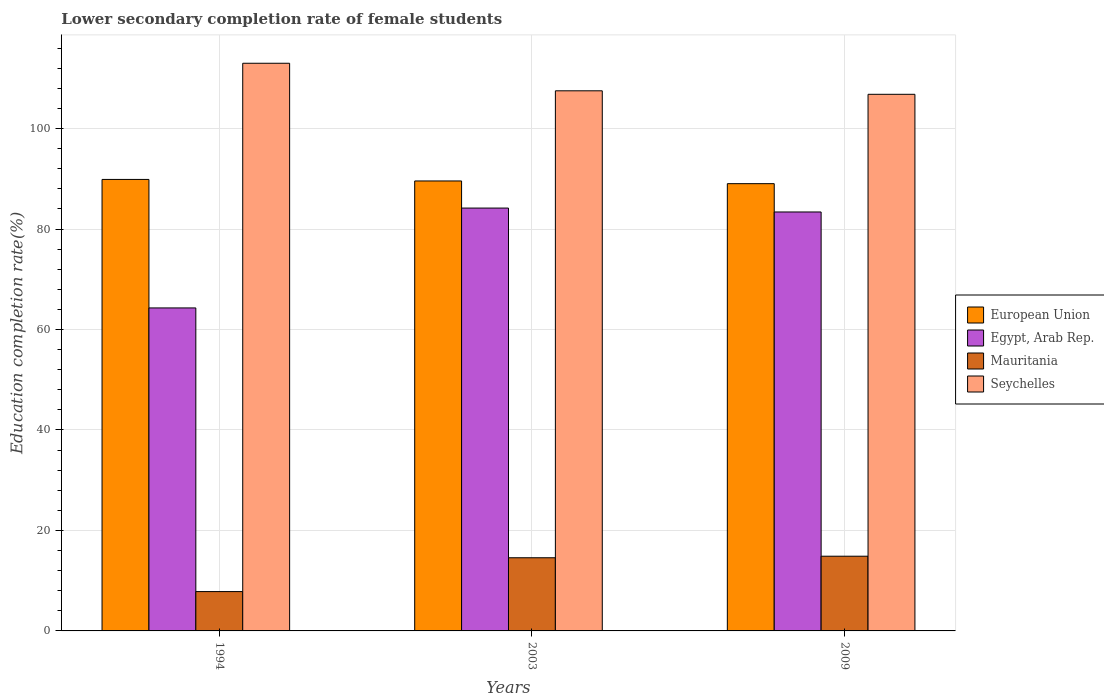How many groups of bars are there?
Your response must be concise. 3. How many bars are there on the 1st tick from the right?
Offer a terse response. 4. In how many cases, is the number of bars for a given year not equal to the number of legend labels?
Offer a very short reply. 0. What is the lower secondary completion rate of female students in European Union in 2003?
Ensure brevity in your answer.  89.57. Across all years, what is the maximum lower secondary completion rate of female students in Egypt, Arab Rep.?
Make the answer very short. 84.18. Across all years, what is the minimum lower secondary completion rate of female students in Egypt, Arab Rep.?
Make the answer very short. 64.3. In which year was the lower secondary completion rate of female students in Egypt, Arab Rep. maximum?
Keep it short and to the point. 2003. What is the total lower secondary completion rate of female students in Egypt, Arab Rep. in the graph?
Give a very brief answer. 231.87. What is the difference between the lower secondary completion rate of female students in Egypt, Arab Rep. in 2003 and that in 2009?
Make the answer very short. 0.78. What is the difference between the lower secondary completion rate of female students in Egypt, Arab Rep. in 2003 and the lower secondary completion rate of female students in European Union in 2009?
Keep it short and to the point. -4.86. What is the average lower secondary completion rate of female students in Seychelles per year?
Provide a succinct answer. 109.11. In the year 1994, what is the difference between the lower secondary completion rate of female students in European Union and lower secondary completion rate of female students in Mauritania?
Ensure brevity in your answer.  82.05. What is the ratio of the lower secondary completion rate of female students in European Union in 1994 to that in 2009?
Give a very brief answer. 1.01. What is the difference between the highest and the second highest lower secondary completion rate of female students in Mauritania?
Keep it short and to the point. 0.31. What is the difference between the highest and the lowest lower secondary completion rate of female students in Mauritania?
Give a very brief answer. 7.04. In how many years, is the lower secondary completion rate of female students in European Union greater than the average lower secondary completion rate of female students in European Union taken over all years?
Provide a succinct answer. 2. Is the sum of the lower secondary completion rate of female students in Mauritania in 1994 and 2009 greater than the maximum lower secondary completion rate of female students in European Union across all years?
Offer a very short reply. No. Is it the case that in every year, the sum of the lower secondary completion rate of female students in Seychelles and lower secondary completion rate of female students in European Union is greater than the sum of lower secondary completion rate of female students in Egypt, Arab Rep. and lower secondary completion rate of female students in Mauritania?
Give a very brief answer. Yes. What does the 1st bar from the left in 2003 represents?
Offer a terse response. European Union. Is it the case that in every year, the sum of the lower secondary completion rate of female students in Seychelles and lower secondary completion rate of female students in Egypt, Arab Rep. is greater than the lower secondary completion rate of female students in Mauritania?
Your response must be concise. Yes. Are all the bars in the graph horizontal?
Keep it short and to the point. No. What is the difference between two consecutive major ticks on the Y-axis?
Your response must be concise. 20. Are the values on the major ticks of Y-axis written in scientific E-notation?
Offer a very short reply. No. Does the graph contain grids?
Ensure brevity in your answer.  Yes. How are the legend labels stacked?
Provide a succinct answer. Vertical. What is the title of the graph?
Your answer should be very brief. Lower secondary completion rate of female students. Does "Syrian Arab Republic" appear as one of the legend labels in the graph?
Your response must be concise. No. What is the label or title of the Y-axis?
Your answer should be very brief. Education completion rate(%). What is the Education completion rate(%) of European Union in 1994?
Give a very brief answer. 89.88. What is the Education completion rate(%) of Egypt, Arab Rep. in 1994?
Give a very brief answer. 64.3. What is the Education completion rate(%) of Mauritania in 1994?
Your answer should be compact. 7.83. What is the Education completion rate(%) in Seychelles in 1994?
Your response must be concise. 113. What is the Education completion rate(%) in European Union in 2003?
Keep it short and to the point. 89.57. What is the Education completion rate(%) in Egypt, Arab Rep. in 2003?
Make the answer very short. 84.18. What is the Education completion rate(%) of Mauritania in 2003?
Provide a succinct answer. 14.57. What is the Education completion rate(%) of Seychelles in 2003?
Ensure brevity in your answer.  107.52. What is the Education completion rate(%) of European Union in 2009?
Offer a very short reply. 89.03. What is the Education completion rate(%) in Egypt, Arab Rep. in 2009?
Your response must be concise. 83.4. What is the Education completion rate(%) of Mauritania in 2009?
Your answer should be very brief. 14.87. What is the Education completion rate(%) of Seychelles in 2009?
Offer a very short reply. 106.82. Across all years, what is the maximum Education completion rate(%) of European Union?
Your response must be concise. 89.88. Across all years, what is the maximum Education completion rate(%) in Egypt, Arab Rep.?
Give a very brief answer. 84.18. Across all years, what is the maximum Education completion rate(%) of Mauritania?
Your response must be concise. 14.87. Across all years, what is the maximum Education completion rate(%) of Seychelles?
Offer a terse response. 113. Across all years, what is the minimum Education completion rate(%) in European Union?
Offer a very short reply. 89.03. Across all years, what is the minimum Education completion rate(%) of Egypt, Arab Rep.?
Provide a short and direct response. 64.3. Across all years, what is the minimum Education completion rate(%) in Mauritania?
Your answer should be compact. 7.83. Across all years, what is the minimum Education completion rate(%) of Seychelles?
Your answer should be very brief. 106.82. What is the total Education completion rate(%) of European Union in the graph?
Offer a very short reply. 268.48. What is the total Education completion rate(%) in Egypt, Arab Rep. in the graph?
Your answer should be compact. 231.87. What is the total Education completion rate(%) of Mauritania in the graph?
Ensure brevity in your answer.  37.27. What is the total Education completion rate(%) in Seychelles in the graph?
Make the answer very short. 327.34. What is the difference between the Education completion rate(%) of European Union in 1994 and that in 2003?
Ensure brevity in your answer.  0.3. What is the difference between the Education completion rate(%) of Egypt, Arab Rep. in 1994 and that in 2003?
Keep it short and to the point. -19.88. What is the difference between the Education completion rate(%) of Mauritania in 1994 and that in 2003?
Provide a short and direct response. -6.74. What is the difference between the Education completion rate(%) in Seychelles in 1994 and that in 2003?
Provide a short and direct response. 5.48. What is the difference between the Education completion rate(%) in European Union in 1994 and that in 2009?
Offer a very short reply. 0.84. What is the difference between the Education completion rate(%) of Egypt, Arab Rep. in 1994 and that in 2009?
Keep it short and to the point. -19.1. What is the difference between the Education completion rate(%) of Mauritania in 1994 and that in 2009?
Offer a terse response. -7.04. What is the difference between the Education completion rate(%) in Seychelles in 1994 and that in 2009?
Provide a short and direct response. 6.18. What is the difference between the Education completion rate(%) in European Union in 2003 and that in 2009?
Make the answer very short. 0.54. What is the difference between the Education completion rate(%) of Egypt, Arab Rep. in 2003 and that in 2009?
Your response must be concise. 0.78. What is the difference between the Education completion rate(%) in Mauritania in 2003 and that in 2009?
Your answer should be very brief. -0.31. What is the difference between the Education completion rate(%) in Seychelles in 2003 and that in 2009?
Provide a short and direct response. 0.7. What is the difference between the Education completion rate(%) in European Union in 1994 and the Education completion rate(%) in Egypt, Arab Rep. in 2003?
Keep it short and to the point. 5.7. What is the difference between the Education completion rate(%) of European Union in 1994 and the Education completion rate(%) of Mauritania in 2003?
Provide a short and direct response. 75.31. What is the difference between the Education completion rate(%) in European Union in 1994 and the Education completion rate(%) in Seychelles in 2003?
Your answer should be compact. -17.64. What is the difference between the Education completion rate(%) of Egypt, Arab Rep. in 1994 and the Education completion rate(%) of Mauritania in 2003?
Your response must be concise. 49.73. What is the difference between the Education completion rate(%) of Egypt, Arab Rep. in 1994 and the Education completion rate(%) of Seychelles in 2003?
Keep it short and to the point. -43.22. What is the difference between the Education completion rate(%) of Mauritania in 1994 and the Education completion rate(%) of Seychelles in 2003?
Ensure brevity in your answer.  -99.69. What is the difference between the Education completion rate(%) of European Union in 1994 and the Education completion rate(%) of Egypt, Arab Rep. in 2009?
Offer a very short reply. 6.48. What is the difference between the Education completion rate(%) of European Union in 1994 and the Education completion rate(%) of Mauritania in 2009?
Offer a terse response. 75. What is the difference between the Education completion rate(%) of European Union in 1994 and the Education completion rate(%) of Seychelles in 2009?
Give a very brief answer. -16.95. What is the difference between the Education completion rate(%) in Egypt, Arab Rep. in 1994 and the Education completion rate(%) in Mauritania in 2009?
Your answer should be compact. 49.42. What is the difference between the Education completion rate(%) in Egypt, Arab Rep. in 1994 and the Education completion rate(%) in Seychelles in 2009?
Your answer should be compact. -42.52. What is the difference between the Education completion rate(%) in Mauritania in 1994 and the Education completion rate(%) in Seychelles in 2009?
Provide a short and direct response. -98.99. What is the difference between the Education completion rate(%) of European Union in 2003 and the Education completion rate(%) of Egypt, Arab Rep. in 2009?
Offer a terse response. 6.17. What is the difference between the Education completion rate(%) in European Union in 2003 and the Education completion rate(%) in Mauritania in 2009?
Provide a short and direct response. 74.7. What is the difference between the Education completion rate(%) of European Union in 2003 and the Education completion rate(%) of Seychelles in 2009?
Your answer should be very brief. -17.25. What is the difference between the Education completion rate(%) in Egypt, Arab Rep. in 2003 and the Education completion rate(%) in Mauritania in 2009?
Give a very brief answer. 69.3. What is the difference between the Education completion rate(%) of Egypt, Arab Rep. in 2003 and the Education completion rate(%) of Seychelles in 2009?
Your response must be concise. -22.64. What is the difference between the Education completion rate(%) of Mauritania in 2003 and the Education completion rate(%) of Seychelles in 2009?
Make the answer very short. -92.26. What is the average Education completion rate(%) of European Union per year?
Offer a terse response. 89.49. What is the average Education completion rate(%) in Egypt, Arab Rep. per year?
Offer a very short reply. 77.29. What is the average Education completion rate(%) of Mauritania per year?
Your answer should be compact. 12.42. What is the average Education completion rate(%) in Seychelles per year?
Keep it short and to the point. 109.11. In the year 1994, what is the difference between the Education completion rate(%) in European Union and Education completion rate(%) in Egypt, Arab Rep.?
Your response must be concise. 25.58. In the year 1994, what is the difference between the Education completion rate(%) of European Union and Education completion rate(%) of Mauritania?
Offer a very short reply. 82.05. In the year 1994, what is the difference between the Education completion rate(%) in European Union and Education completion rate(%) in Seychelles?
Your answer should be very brief. -23.13. In the year 1994, what is the difference between the Education completion rate(%) in Egypt, Arab Rep. and Education completion rate(%) in Mauritania?
Offer a terse response. 56.47. In the year 1994, what is the difference between the Education completion rate(%) of Egypt, Arab Rep. and Education completion rate(%) of Seychelles?
Your response must be concise. -48.71. In the year 1994, what is the difference between the Education completion rate(%) of Mauritania and Education completion rate(%) of Seychelles?
Your answer should be compact. -105.17. In the year 2003, what is the difference between the Education completion rate(%) of European Union and Education completion rate(%) of Egypt, Arab Rep.?
Your answer should be very brief. 5.4. In the year 2003, what is the difference between the Education completion rate(%) in European Union and Education completion rate(%) in Mauritania?
Provide a short and direct response. 75.01. In the year 2003, what is the difference between the Education completion rate(%) of European Union and Education completion rate(%) of Seychelles?
Give a very brief answer. -17.94. In the year 2003, what is the difference between the Education completion rate(%) in Egypt, Arab Rep. and Education completion rate(%) in Mauritania?
Keep it short and to the point. 69.61. In the year 2003, what is the difference between the Education completion rate(%) in Egypt, Arab Rep. and Education completion rate(%) in Seychelles?
Provide a short and direct response. -23.34. In the year 2003, what is the difference between the Education completion rate(%) in Mauritania and Education completion rate(%) in Seychelles?
Give a very brief answer. -92.95. In the year 2009, what is the difference between the Education completion rate(%) in European Union and Education completion rate(%) in Egypt, Arab Rep.?
Keep it short and to the point. 5.63. In the year 2009, what is the difference between the Education completion rate(%) in European Union and Education completion rate(%) in Mauritania?
Make the answer very short. 74.16. In the year 2009, what is the difference between the Education completion rate(%) in European Union and Education completion rate(%) in Seychelles?
Provide a succinct answer. -17.79. In the year 2009, what is the difference between the Education completion rate(%) of Egypt, Arab Rep. and Education completion rate(%) of Mauritania?
Keep it short and to the point. 68.53. In the year 2009, what is the difference between the Education completion rate(%) in Egypt, Arab Rep. and Education completion rate(%) in Seychelles?
Your answer should be very brief. -23.42. In the year 2009, what is the difference between the Education completion rate(%) of Mauritania and Education completion rate(%) of Seychelles?
Provide a succinct answer. -91.95. What is the ratio of the Education completion rate(%) of Egypt, Arab Rep. in 1994 to that in 2003?
Make the answer very short. 0.76. What is the ratio of the Education completion rate(%) of Mauritania in 1994 to that in 2003?
Keep it short and to the point. 0.54. What is the ratio of the Education completion rate(%) in Seychelles in 1994 to that in 2003?
Provide a short and direct response. 1.05. What is the ratio of the Education completion rate(%) of European Union in 1994 to that in 2009?
Your answer should be compact. 1.01. What is the ratio of the Education completion rate(%) in Egypt, Arab Rep. in 1994 to that in 2009?
Make the answer very short. 0.77. What is the ratio of the Education completion rate(%) in Mauritania in 1994 to that in 2009?
Offer a very short reply. 0.53. What is the ratio of the Education completion rate(%) in Seychelles in 1994 to that in 2009?
Offer a terse response. 1.06. What is the ratio of the Education completion rate(%) in European Union in 2003 to that in 2009?
Your response must be concise. 1.01. What is the ratio of the Education completion rate(%) of Egypt, Arab Rep. in 2003 to that in 2009?
Make the answer very short. 1.01. What is the ratio of the Education completion rate(%) in Mauritania in 2003 to that in 2009?
Your answer should be compact. 0.98. What is the difference between the highest and the second highest Education completion rate(%) of European Union?
Your answer should be compact. 0.3. What is the difference between the highest and the second highest Education completion rate(%) in Egypt, Arab Rep.?
Make the answer very short. 0.78. What is the difference between the highest and the second highest Education completion rate(%) of Mauritania?
Give a very brief answer. 0.31. What is the difference between the highest and the second highest Education completion rate(%) of Seychelles?
Your response must be concise. 5.48. What is the difference between the highest and the lowest Education completion rate(%) in European Union?
Your answer should be compact. 0.84. What is the difference between the highest and the lowest Education completion rate(%) of Egypt, Arab Rep.?
Give a very brief answer. 19.88. What is the difference between the highest and the lowest Education completion rate(%) of Mauritania?
Your answer should be compact. 7.04. What is the difference between the highest and the lowest Education completion rate(%) in Seychelles?
Your answer should be very brief. 6.18. 